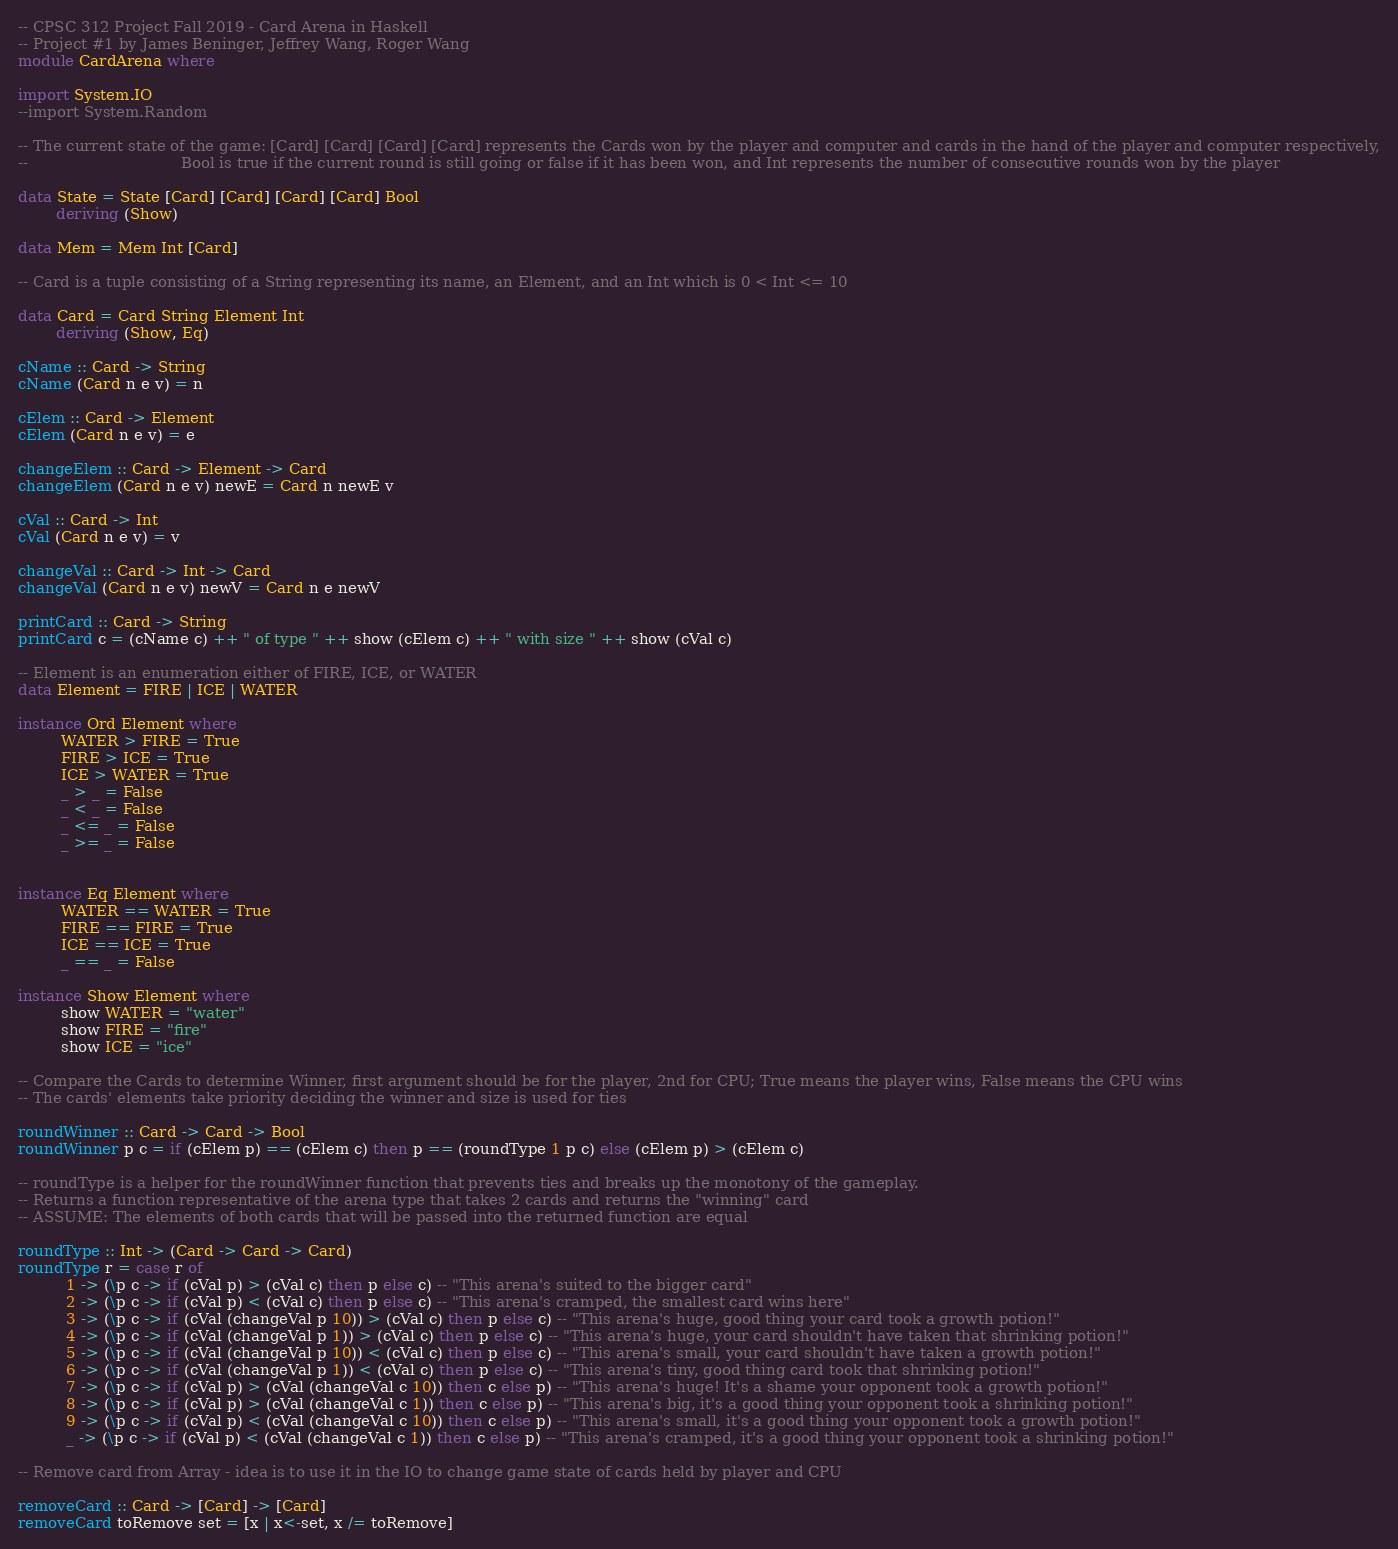Convert code to text. <code><loc_0><loc_0><loc_500><loc_500><_Haskell_>-- CPSC 312 Project Fall 2019 - Card Arena in Haskell
-- Project #1 by James Beninger, Jeffrey Wang, Roger Wang
module CardArena where

import System.IO
--import System.Random

-- The current state of the game: [Card] [Card] [Card] [Card] represents the Cards won by the player and computer and cards in the hand of the player and computer respectively,
--                                Bool is true if the current round is still going or false if it has been won, and Int represents the number of consecutive rounds won by the player

data State = State [Card] [Card] [Card] [Card] Bool
        deriving (Show)

data Mem = Mem Int [Card]

-- Card is a tuple consisting of a String representing its name, an Element, and an Int which is 0 < Int <= 10

data Card = Card String Element Int
        deriving (Show, Eq)

cName :: Card -> String
cName (Card n e v) = n

cElem :: Card -> Element
cElem (Card n e v) = e

changeElem :: Card -> Element -> Card
changeElem (Card n e v) newE = Card n newE v

cVal :: Card -> Int
cVal (Card n e v) = v

changeVal :: Card -> Int -> Card
changeVal (Card n e v) newV = Card n e newV

printCard :: Card -> String
printCard c = (cName c) ++ " of type " ++ show (cElem c) ++ " with size " ++ show (cVal c)

-- Element is an enumeration either of FIRE, ICE, or WATER
data Element = FIRE | ICE | WATER

instance Ord Element where
         WATER > FIRE = True
         FIRE > ICE = True
         ICE > WATER = True
         _ > _ = False
         _ < _ = False
         _ <= _ = False
         _ >= _ = False
         

instance Eq Element where
         WATER == WATER = True
         FIRE == FIRE = True
         ICE == ICE = True
         _ == _ = False

instance Show Element where
         show WATER = "water"
         show FIRE = "fire"
         show ICE = "ice"

-- Compare the Cards to determine Winner, first argument should be for the player, 2nd for CPU; True means the player wins, False means the CPU wins
-- The cards' elements take priority deciding the winner and size is used for ties

roundWinner :: Card -> Card -> Bool
roundWinner p c = if (cElem p) == (cElem c) then p == (roundType 1 p c) else (cElem p) > (cElem c)

-- roundType is a helper for the roundWinner function that prevents ties and breaks up the monotony of the gameplay.
-- Returns a function representative of the arena type that takes 2 cards and returns the "winning" card
-- ASSUME: The elements of both cards that will be passed into the returned function are equal

roundType :: Int -> (Card -> Card -> Card)
roundType r = case r of
          1 -> (\p c -> if (cVal p) > (cVal c) then p else c) -- "This arena's suited to the bigger card"
          2 -> (\p c -> if (cVal p) < (cVal c) then p else c) -- "This arena's cramped, the smallest card wins here"
          3 -> (\p c -> if (cVal (changeVal p 10)) > (cVal c) then p else c) -- "This arena's huge, good thing your card took a growth potion!"
          4 -> (\p c -> if (cVal (changeVal p 1)) > (cVal c) then p else c) -- "This arena's huge, your card shouldn't have taken that shrinking potion!"
          5 -> (\p c -> if (cVal (changeVal p 10)) < (cVal c) then p else c) -- "This arena's small, your card shouldn't have taken a growth potion!"
          6 -> (\p c -> if (cVal (changeVal p 1)) < (cVal c) then p else c) -- "This arena's tiny, good thing card took that shrinking potion!"
          7 -> (\p c -> if (cVal p) > (cVal (changeVal c 10)) then c else p) -- "This arena's huge! It's a shame your opponent took a growth potion!"
          8 -> (\p c -> if (cVal p) > (cVal (changeVal c 1)) then c else p) -- "This arena's big, it's a good thing your opponent took a shrinking potion!"
          9 -> (\p c -> if (cVal p) < (cVal (changeVal c 10)) then c else p) -- "This arena's small, it's a good thing your opponent took a growth potion!"
          _ -> (\p c -> if (cVal p) < (cVal (changeVal c 1)) then c else p) -- "This arena's cramped, it's a good thing your opponent took a shrinking potion!"

-- Remove card from Array - idea is to use it in the IO to change game state of cards held by player and CPU

removeCard :: Card -> [Card] -> [Card]
removeCard toRemove set = [x | x<-set, x /= toRemove]
</code> 